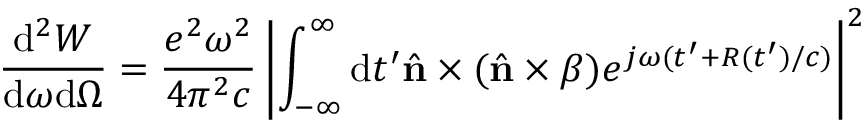Convert formula to latex. <formula><loc_0><loc_0><loc_500><loc_500>\frac { d ^ { 2 } W } { d \omega d \Omega } = \frac { e ^ { 2 } \omega ^ { 2 } } { 4 \pi ^ { 2 } c } \left | \int _ { - \infty } ^ { \infty } d t ^ { \prime } { \hat { n } \times ( \hat { n } \times \beta ) } e ^ { j \omega ( t ^ { \prime } + R ( t ^ { \prime } ) / c ) } \right | ^ { 2 }</formula> 